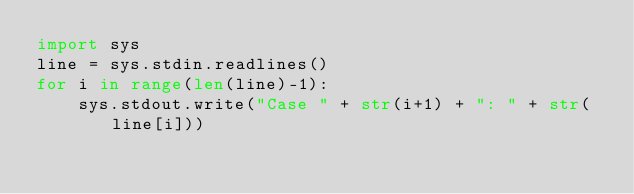<code> <loc_0><loc_0><loc_500><loc_500><_Python_>import sys
line = sys.stdin.readlines()
for i in range(len(line)-1):
    sys.stdout.write("Case " + str(i+1) + ": " + str(line[i]))

</code> 